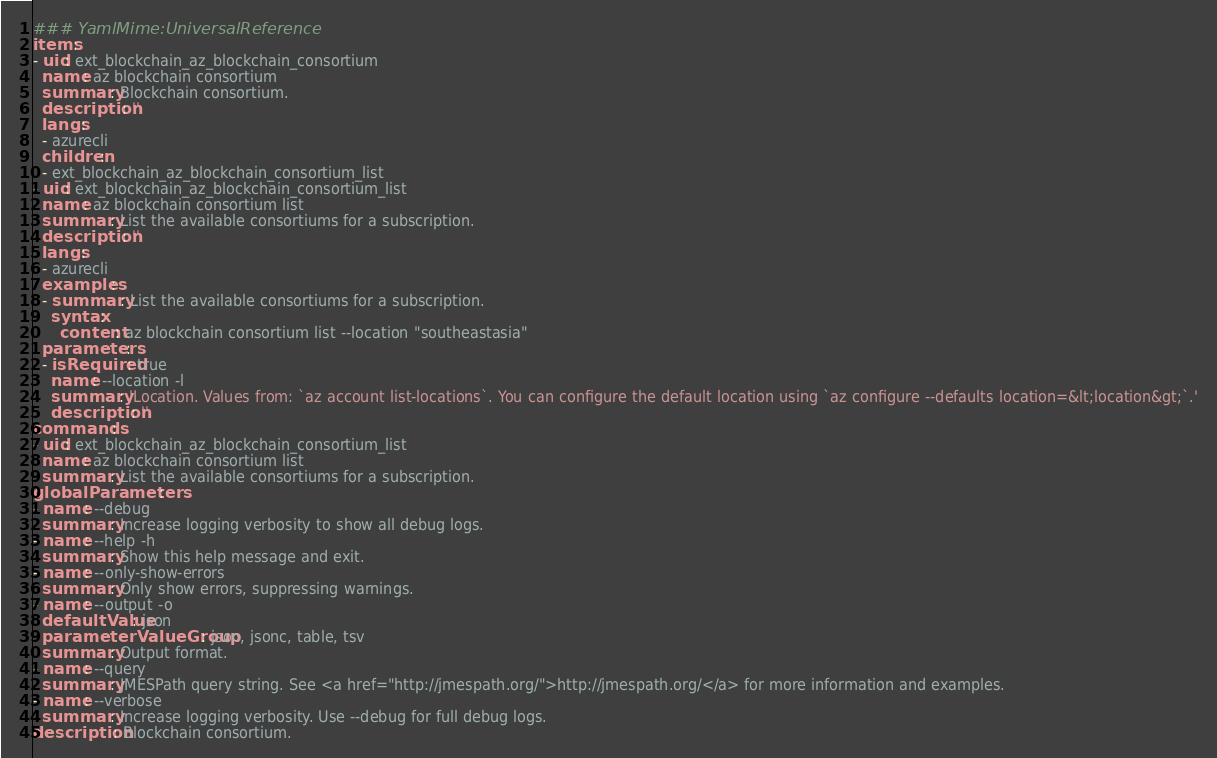Convert code to text. <code><loc_0><loc_0><loc_500><loc_500><_YAML_>### YamlMime:UniversalReference
items:
- uid: ext_blockchain_az_blockchain_consortium
  name: az blockchain consortium
  summary: Blockchain consortium.
  description: ''
  langs:
  - azurecli
  children:
  - ext_blockchain_az_blockchain_consortium_list
- uid: ext_blockchain_az_blockchain_consortium_list
  name: az blockchain consortium list
  summary: List the available consortiums for a subscription.
  description: ''
  langs:
  - azurecli
  examples:
  - summary: List the available consortiums for a subscription.
    syntax:
      content: az blockchain consortium list --location "southeastasia"
  parameters:
  - isRequired: true
    name: --location -l
    summary: 'Location. Values from: `az account list-locations`. You can configure the default location using `az configure --defaults location=&lt;location&gt;`.'
    description: ''
commands:
- uid: ext_blockchain_az_blockchain_consortium_list
  name: az blockchain consortium list
  summary: List the available consortiums for a subscription.
globalParameters:
- name: --debug
  summary: Increase logging verbosity to show all debug logs.
- name: --help -h
  summary: Show this help message and exit.
- name: --only-show-errors
  summary: Only show errors, suppressing warnings.
- name: --output -o
  defaultValue: json
  parameterValueGroup: json, jsonc, table, tsv
  summary: Output format.
- name: --query
  summary: JMESPath query string. See <a href="http://jmespath.org/">http://jmespath.org/</a> for more information and examples.
- name: --verbose
  summary: Increase logging verbosity. Use --debug for full debug logs.
description: Blockchain consortium.
</code> 